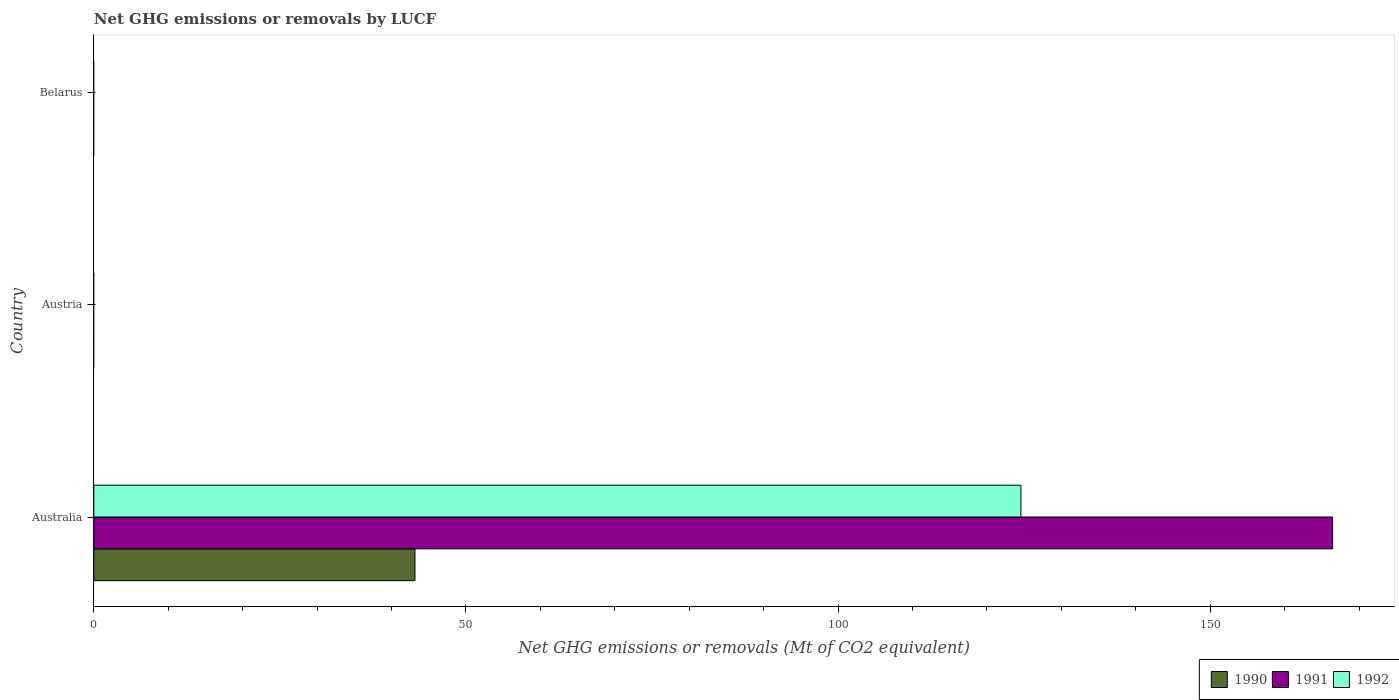Are the number of bars on each tick of the Y-axis equal?
Your response must be concise. No. How many bars are there on the 2nd tick from the top?
Ensure brevity in your answer.  0. What is the label of the 1st group of bars from the top?
Offer a terse response. Belarus. What is the net GHG emissions or removals by LUCF in 1992 in Australia?
Give a very brief answer. 124.57. Across all countries, what is the maximum net GHG emissions or removals by LUCF in 1992?
Offer a terse response. 124.57. Across all countries, what is the minimum net GHG emissions or removals by LUCF in 1990?
Give a very brief answer. 0. In which country was the net GHG emissions or removals by LUCF in 1992 maximum?
Your answer should be very brief. Australia. What is the total net GHG emissions or removals by LUCF in 1991 in the graph?
Offer a terse response. 166.44. What is the average net GHG emissions or removals by LUCF in 1990 per country?
Offer a terse response. 14.38. What is the difference between the net GHG emissions or removals by LUCF in 1990 and net GHG emissions or removals by LUCF in 1991 in Australia?
Offer a very short reply. -123.29. In how many countries, is the net GHG emissions or removals by LUCF in 1992 greater than 50 Mt?
Offer a very short reply. 1. What is the difference between the highest and the lowest net GHG emissions or removals by LUCF in 1990?
Your answer should be compact. 43.15. In how many countries, is the net GHG emissions or removals by LUCF in 1992 greater than the average net GHG emissions or removals by LUCF in 1992 taken over all countries?
Ensure brevity in your answer.  1. How many bars are there?
Your answer should be very brief. 3. How many countries are there in the graph?
Provide a succinct answer. 3. Are the values on the major ticks of X-axis written in scientific E-notation?
Provide a short and direct response. No. How many legend labels are there?
Your response must be concise. 3. How are the legend labels stacked?
Make the answer very short. Horizontal. What is the title of the graph?
Make the answer very short. Net GHG emissions or removals by LUCF. Does "1988" appear as one of the legend labels in the graph?
Offer a very short reply. No. What is the label or title of the X-axis?
Offer a terse response. Net GHG emissions or removals (Mt of CO2 equivalent). What is the label or title of the Y-axis?
Provide a succinct answer. Country. What is the Net GHG emissions or removals (Mt of CO2 equivalent) of 1990 in Australia?
Offer a terse response. 43.15. What is the Net GHG emissions or removals (Mt of CO2 equivalent) of 1991 in Australia?
Your answer should be very brief. 166.44. What is the Net GHG emissions or removals (Mt of CO2 equivalent) in 1992 in Australia?
Your response must be concise. 124.57. What is the Net GHG emissions or removals (Mt of CO2 equivalent) in 1992 in Austria?
Keep it short and to the point. 0. What is the Net GHG emissions or removals (Mt of CO2 equivalent) in 1990 in Belarus?
Your answer should be compact. 0. What is the Net GHG emissions or removals (Mt of CO2 equivalent) in 1992 in Belarus?
Your answer should be very brief. 0. Across all countries, what is the maximum Net GHG emissions or removals (Mt of CO2 equivalent) in 1990?
Your answer should be compact. 43.15. Across all countries, what is the maximum Net GHG emissions or removals (Mt of CO2 equivalent) of 1991?
Your response must be concise. 166.44. Across all countries, what is the maximum Net GHG emissions or removals (Mt of CO2 equivalent) of 1992?
Offer a terse response. 124.57. Across all countries, what is the minimum Net GHG emissions or removals (Mt of CO2 equivalent) of 1990?
Make the answer very short. 0. Across all countries, what is the minimum Net GHG emissions or removals (Mt of CO2 equivalent) of 1992?
Your answer should be very brief. 0. What is the total Net GHG emissions or removals (Mt of CO2 equivalent) of 1990 in the graph?
Your answer should be compact. 43.15. What is the total Net GHG emissions or removals (Mt of CO2 equivalent) of 1991 in the graph?
Keep it short and to the point. 166.44. What is the total Net GHG emissions or removals (Mt of CO2 equivalent) of 1992 in the graph?
Ensure brevity in your answer.  124.57. What is the average Net GHG emissions or removals (Mt of CO2 equivalent) in 1990 per country?
Your answer should be compact. 14.38. What is the average Net GHG emissions or removals (Mt of CO2 equivalent) of 1991 per country?
Provide a short and direct response. 55.48. What is the average Net GHG emissions or removals (Mt of CO2 equivalent) in 1992 per country?
Ensure brevity in your answer.  41.52. What is the difference between the Net GHG emissions or removals (Mt of CO2 equivalent) of 1990 and Net GHG emissions or removals (Mt of CO2 equivalent) of 1991 in Australia?
Make the answer very short. -123.29. What is the difference between the Net GHG emissions or removals (Mt of CO2 equivalent) of 1990 and Net GHG emissions or removals (Mt of CO2 equivalent) of 1992 in Australia?
Your answer should be compact. -81.42. What is the difference between the Net GHG emissions or removals (Mt of CO2 equivalent) in 1991 and Net GHG emissions or removals (Mt of CO2 equivalent) in 1992 in Australia?
Provide a short and direct response. 41.87. What is the difference between the highest and the lowest Net GHG emissions or removals (Mt of CO2 equivalent) of 1990?
Your answer should be very brief. 43.15. What is the difference between the highest and the lowest Net GHG emissions or removals (Mt of CO2 equivalent) of 1991?
Ensure brevity in your answer.  166.44. What is the difference between the highest and the lowest Net GHG emissions or removals (Mt of CO2 equivalent) of 1992?
Your response must be concise. 124.57. 